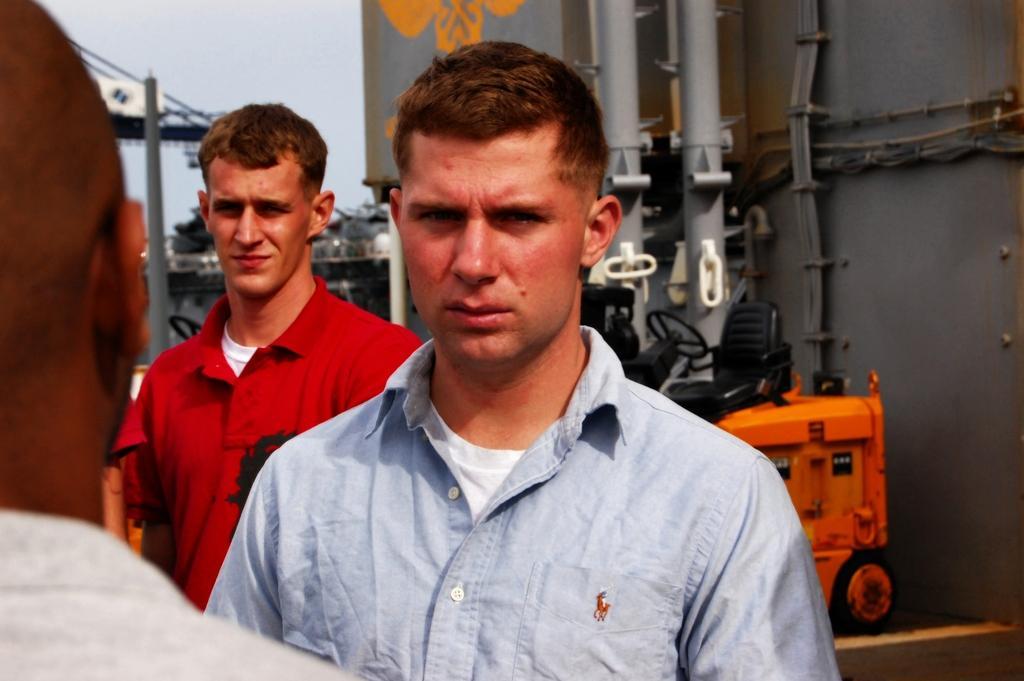Describe this image in one or two sentences. This image is taken outdoors. In the background there is a building. There are a few pipe lines. There is a vehicle parked on the road. At the top of the image there is a sky. On the left side of the image there are three men standing on the ground. 